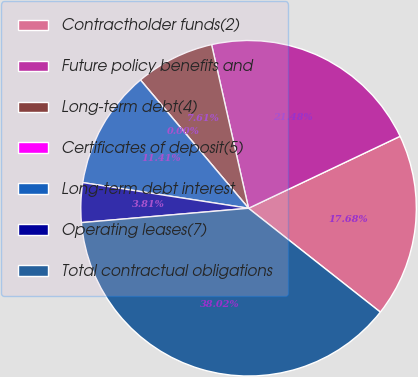Convert chart. <chart><loc_0><loc_0><loc_500><loc_500><pie_chart><fcel>Contractholder funds(2)<fcel>Future policy benefits and<fcel>Long-term debt(4)<fcel>Certificates of deposit(5)<fcel>Long-term debt interest<fcel>Operating leases(7)<fcel>Total contractual obligations<nl><fcel>17.68%<fcel>21.48%<fcel>7.61%<fcel>0.0%<fcel>11.41%<fcel>3.81%<fcel>38.02%<nl></chart> 